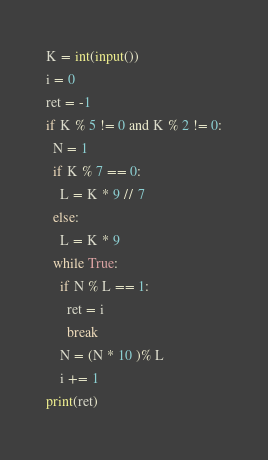Convert code to text. <code><loc_0><loc_0><loc_500><loc_500><_Python_>K = int(input())
i = 0
ret = -1
if K % 5 != 0 and K % 2 != 0:
  N = 1
  if K % 7 == 0:
    L = K * 9 // 7
  else:
    L = K * 9
  while True:
    if N % L == 1:
      ret = i
      break
    N = (N * 10 )% L
    i += 1
print(ret)
</code> 